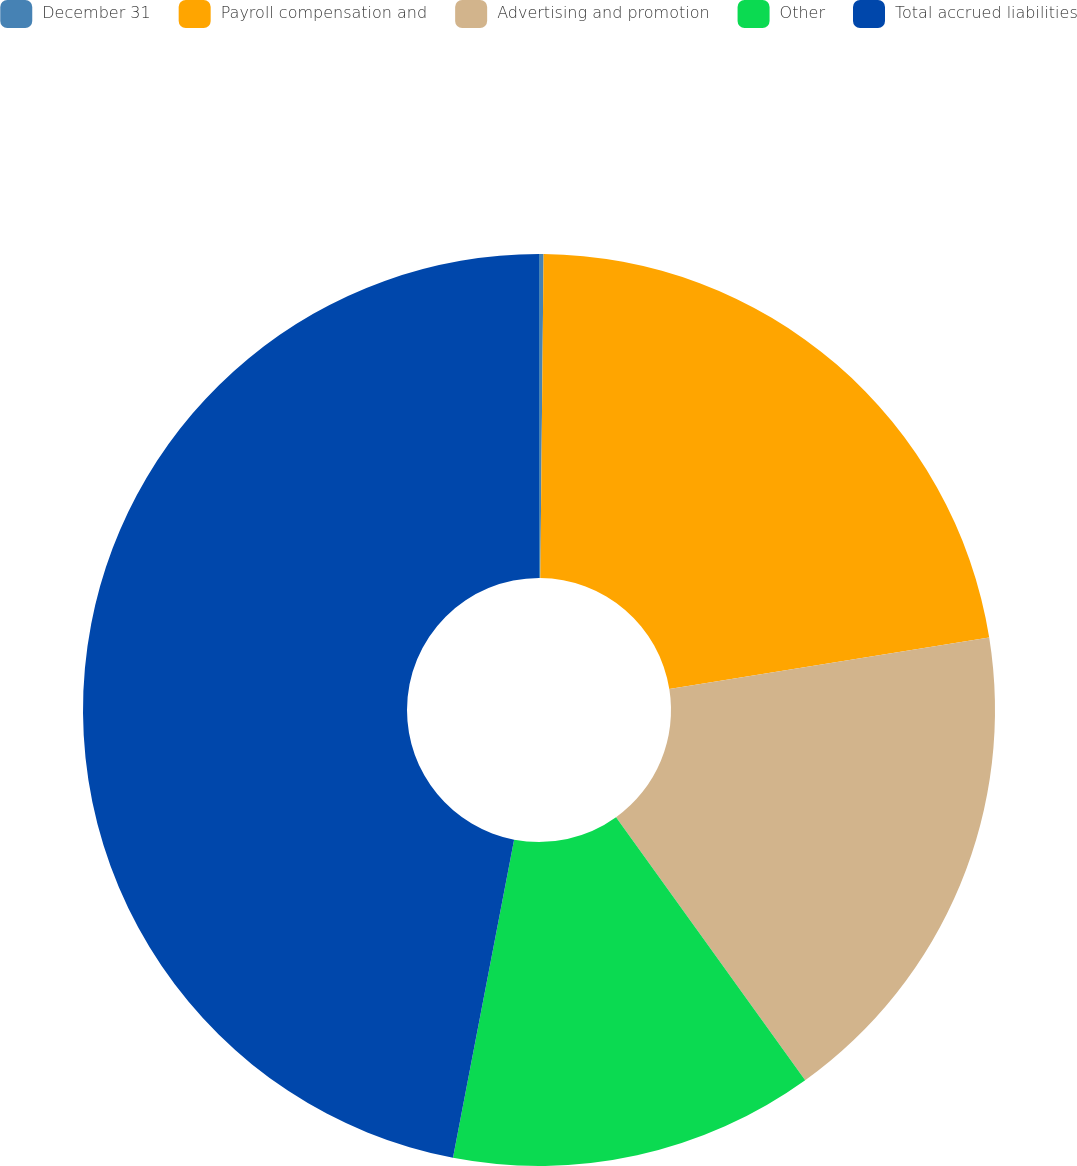Convert chart. <chart><loc_0><loc_0><loc_500><loc_500><pie_chart><fcel>December 31<fcel>Payroll compensation and<fcel>Advertising and promotion<fcel>Other<fcel>Total accrued liabilities<nl><fcel>0.16%<fcel>22.3%<fcel>17.62%<fcel>12.94%<fcel>46.98%<nl></chart> 